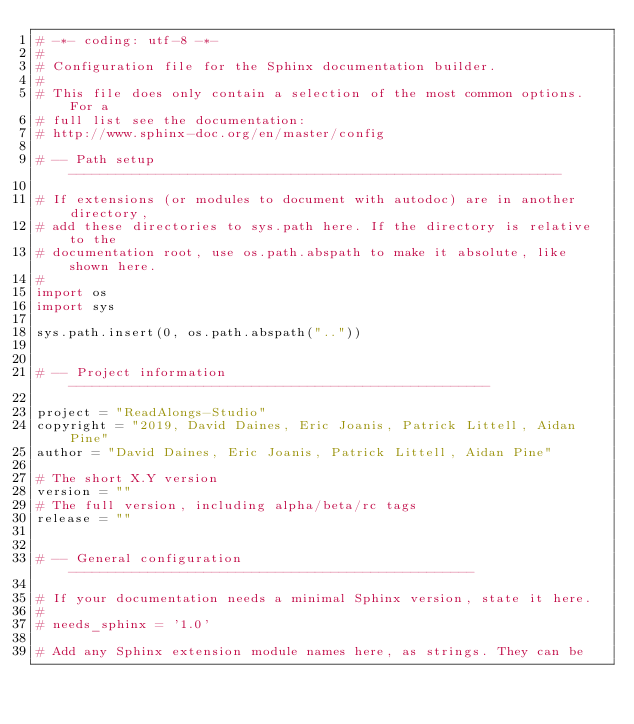<code> <loc_0><loc_0><loc_500><loc_500><_Python_># -*- coding: utf-8 -*-
#
# Configuration file for the Sphinx documentation builder.
#
# This file does only contain a selection of the most common options. For a
# full list see the documentation:
# http://www.sphinx-doc.org/en/master/config

# -- Path setup --------------------------------------------------------------

# If extensions (or modules to document with autodoc) are in another directory,
# add these directories to sys.path here. If the directory is relative to the
# documentation root, use os.path.abspath to make it absolute, like shown here.
#
import os
import sys

sys.path.insert(0, os.path.abspath(".."))


# -- Project information -----------------------------------------------------

project = "ReadAlongs-Studio"
copyright = "2019, David Daines, Eric Joanis, Patrick Littell, Aidan Pine"
author = "David Daines, Eric Joanis, Patrick Littell, Aidan Pine"

# The short X.Y version
version = ""
# The full version, including alpha/beta/rc tags
release = ""


# -- General configuration ---------------------------------------------------

# If your documentation needs a minimal Sphinx version, state it here.
#
# needs_sphinx = '1.0'

# Add any Sphinx extension module names here, as strings. They can be</code> 